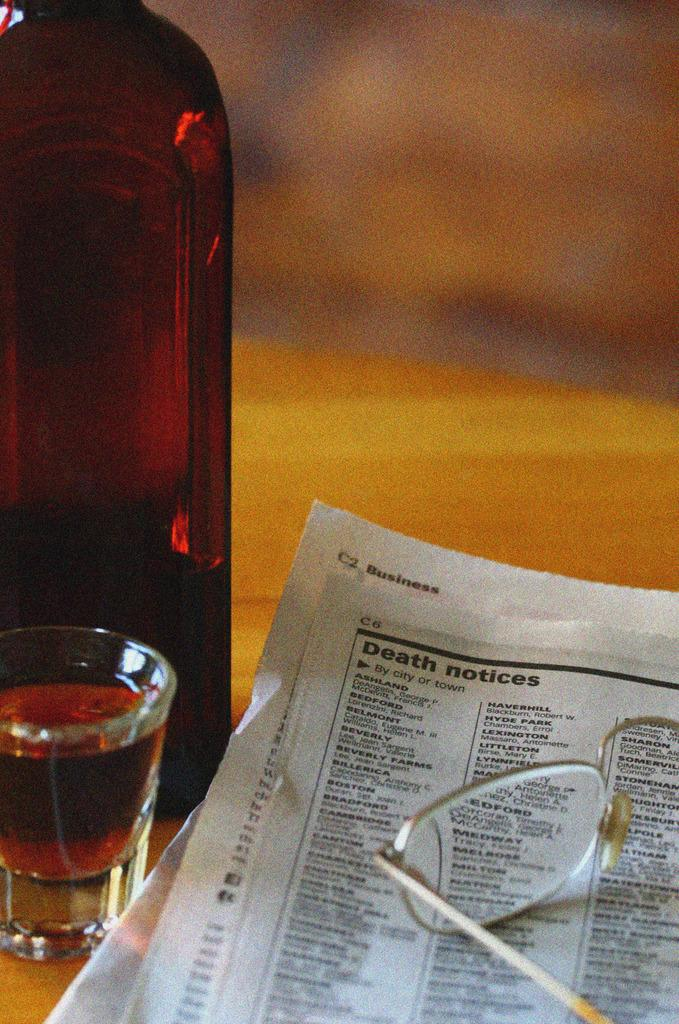<image>
Create a compact narrative representing the image presented. A pair of reading glasses sits on top of a newspaper "Death Notices" section. 